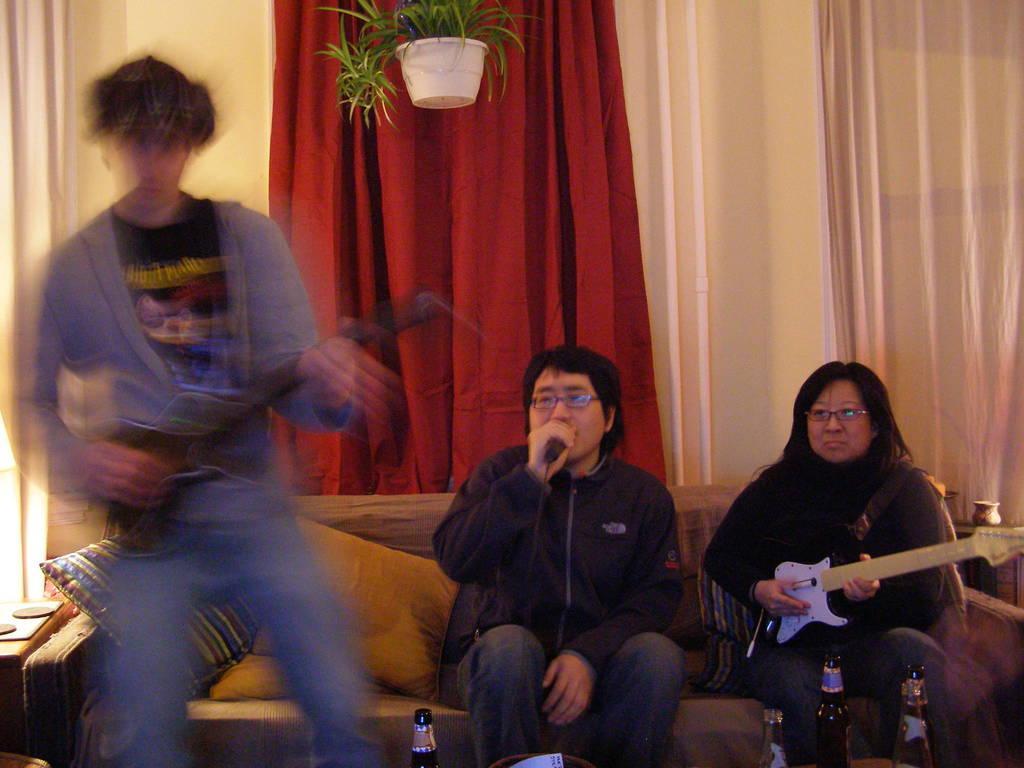How would you summarize this image in a sentence or two? In this image there are three persons two are sitting on the couch and one is standing and at the middle of the image there is a person who is singing and the other persons playing guitar at the top of the image there is a plant. 